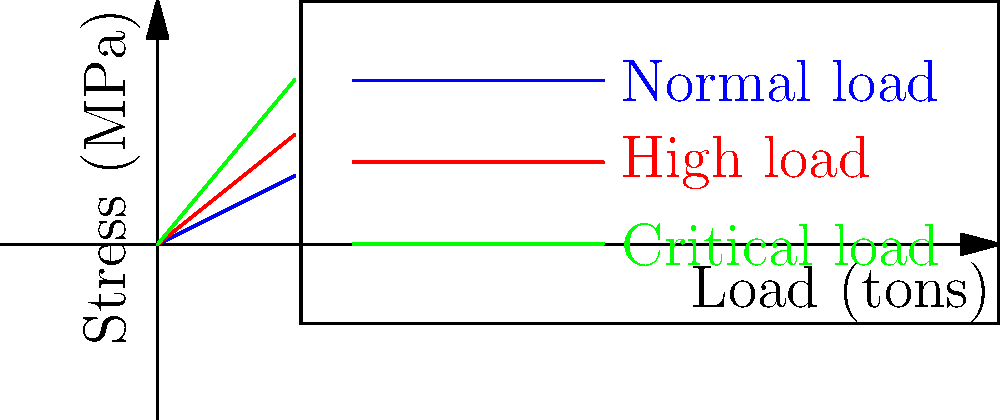Analyze the stress diagram above, which represents the structural integrity of a ship's hull under different load conditions. If the yield strength of the hull material is 80 MPa, what is the maximum safe load the ship can carry before entering the high-risk zone? To determine the maximum safe load, we need to follow these steps:

1. Identify the yield strength: Given as 80 MPa.

2. Analyze the stress curves:
   - Blue line: Normal load condition
   - Red line: High load condition (high-risk zone)
   - Green line: Critical load condition

3. Find the intersection of the yield strength (80 MPa) with the normal load curve:
   Using the equation for the normal load curve: $y = 0.5x$
   Where $y$ is the stress (MPa) and $x$ is the load (tons)
   
   At the yield point: $80 = 0.5x$
   
4. Solve for $x$:
   $x = 80 / 0.5 = 160$ tons

5. Verify that this point is below the high load (red) curve:
   For the high load curve: $y = 0.8x$
   At 160 tons: $y = 0.8 * 160 = 128$ MPa
   
   Since 128 MPa > 80 MPa, the 160-ton load would be in the high-risk zone.

6. Adjust the load to find the maximum safe load:
   We need to find where the normal load curve intersects with the high load curve:
   $0.5x = 0.8x$
   $0 = 0.3x$
   $x = 0$ (trivial solution)

   This means the safe zone ends where the normal and high load curves diverge, which is at the origin.

7. Choose a conservative maximum load:
   To ensure safety, we should choose a load significantly below 160 tons. A reasonable choice would be 100 tons, which gives a stress of 50 MPa (well below the yield strength).
Answer: 100 tons 